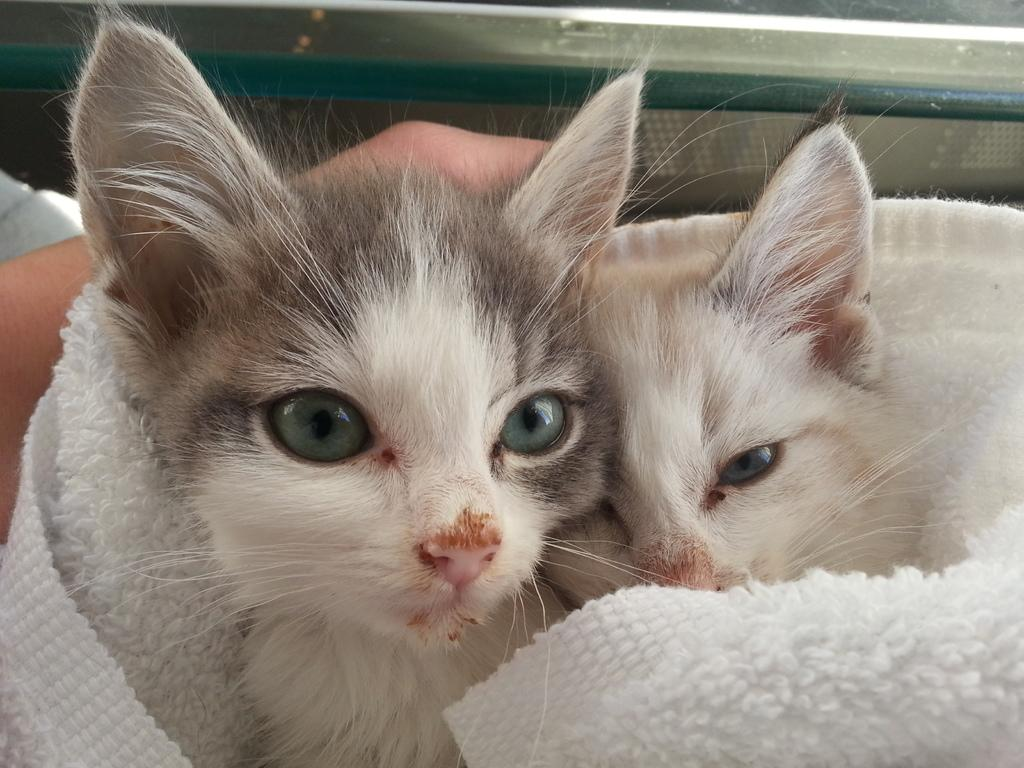How many cats can be seen in the image? There are two cats in the image. What is the cats' location in the image? The cats are on a white cloth. Can you identify any human presence in the image? Yes, there is a hand of a person visible behind the cats. What is the appearance of the object at the top of the image? The object at the top of the image appears to be truncated. What type of honey is being served to the cats in the image? There is no honey or any food being served to the cats in the image; they are simply sitting on a white cloth. 